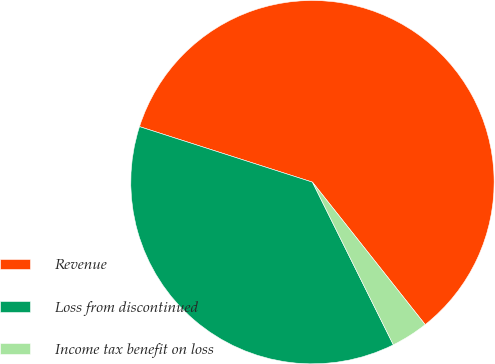Convert chart. <chart><loc_0><loc_0><loc_500><loc_500><pie_chart><fcel>Revenue<fcel>Loss from discontinued<fcel>Income tax benefit on loss<nl><fcel>59.4%<fcel>37.29%<fcel>3.31%<nl></chart> 